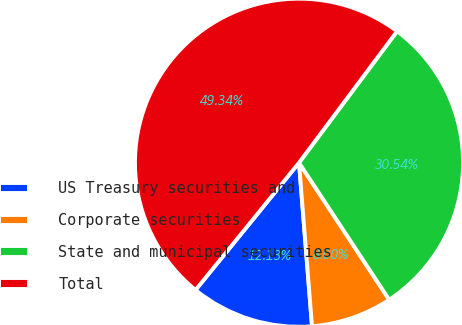<chart> <loc_0><loc_0><loc_500><loc_500><pie_chart><fcel>US Treasury securities and<fcel>Corporate securities<fcel>State and municipal securities<fcel>Total<nl><fcel>12.13%<fcel>8.0%<fcel>30.54%<fcel>49.34%<nl></chart> 